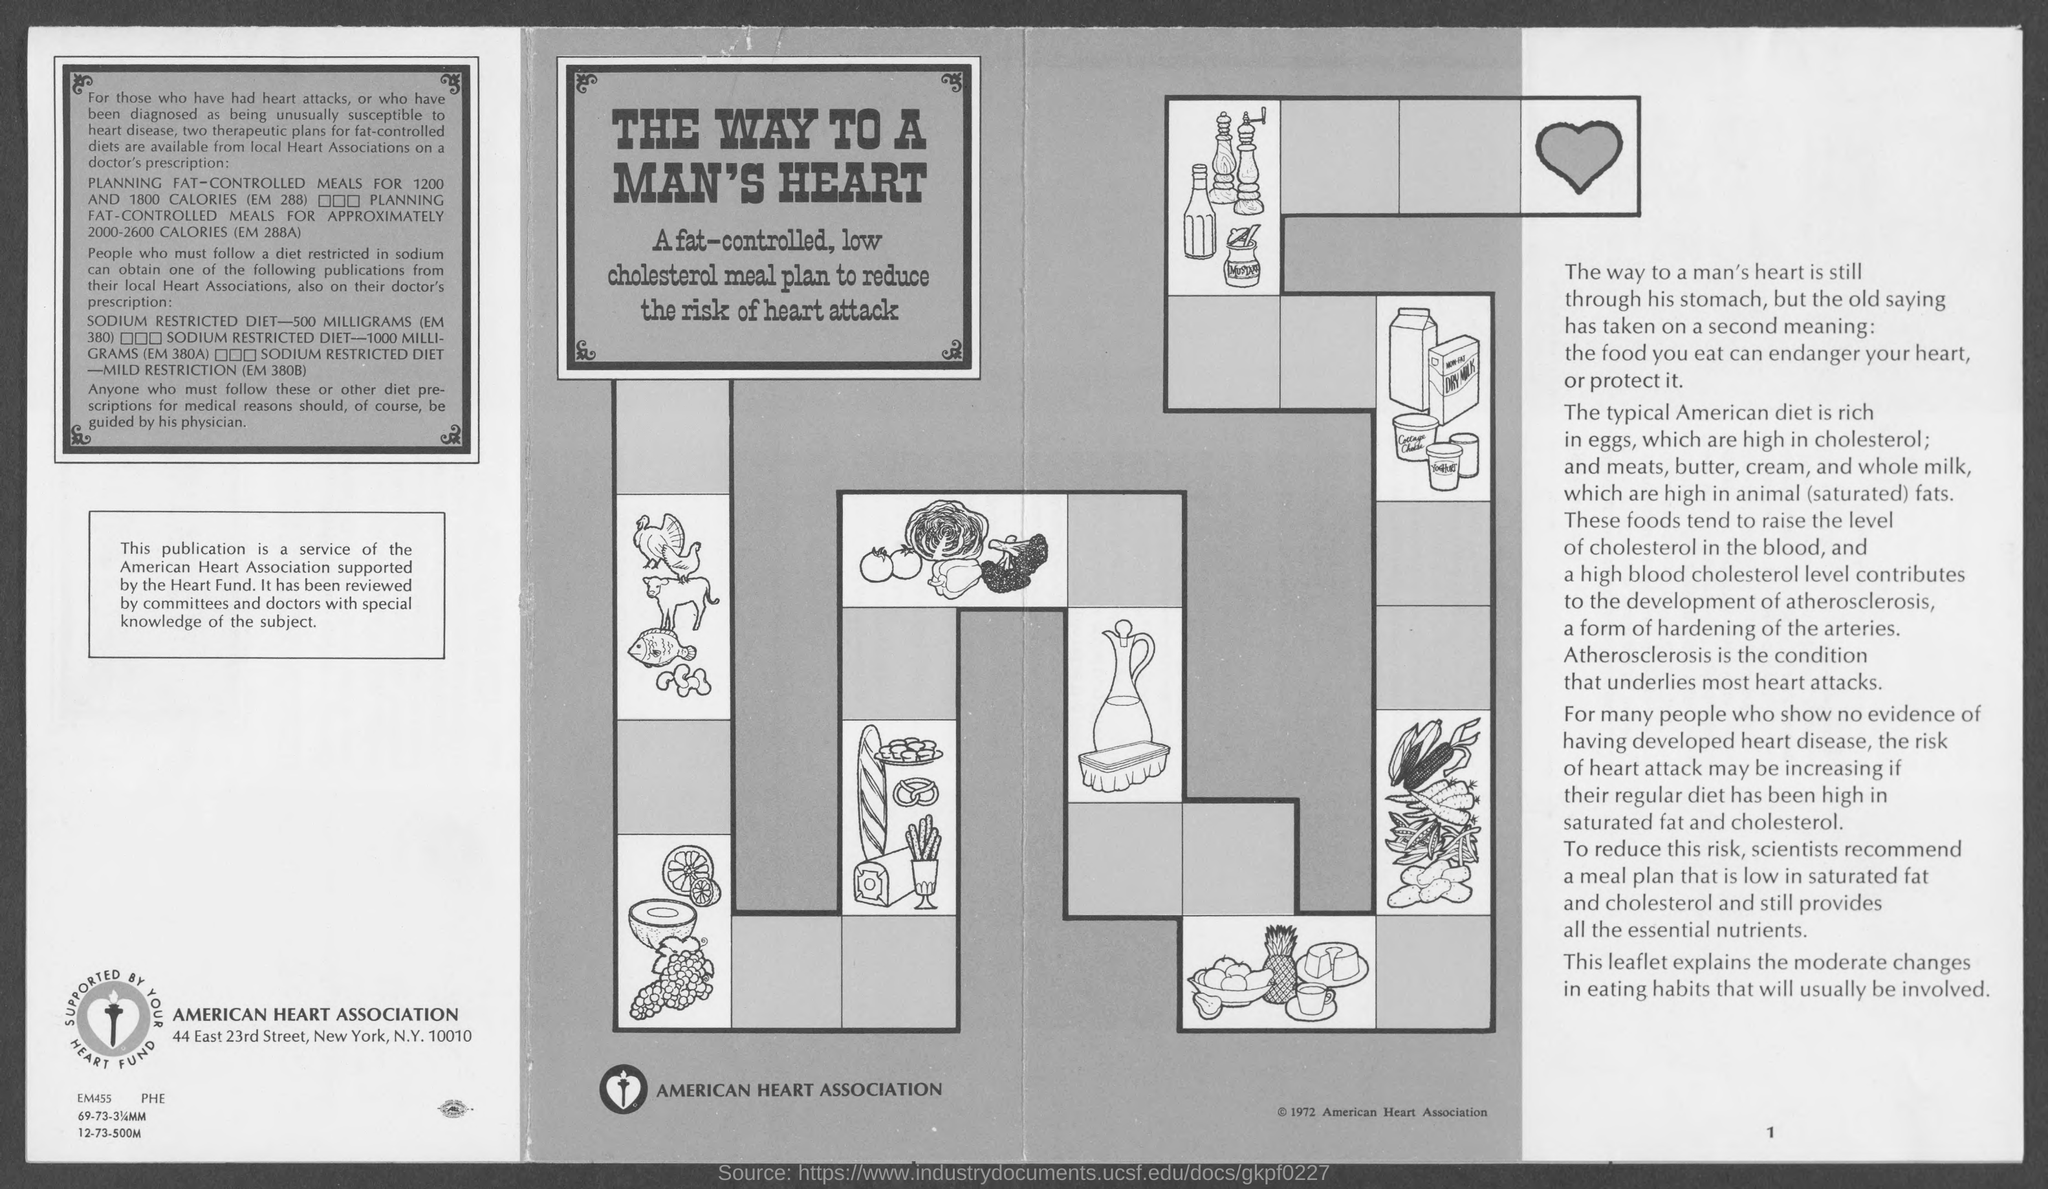What is the name of heart association ?
Keep it short and to the point. American Heart Association. In which street is american heart association at ?
Make the answer very short. 23rd street. What is the page number at bottom- right of the page ?
Your answer should be very brief. 1. 